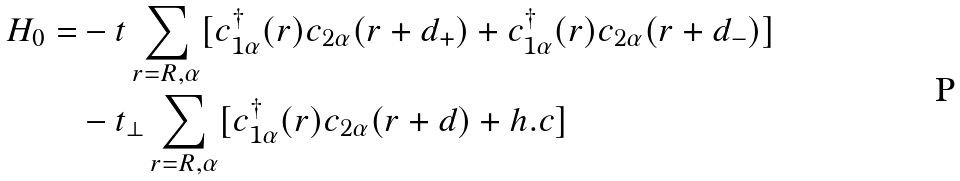Convert formula to latex. <formula><loc_0><loc_0><loc_500><loc_500>H _ { 0 } = & - t \sum _ { r = R , \alpha } [ c _ { 1 \alpha } ^ { \dag } ( r ) c _ { 2 \alpha } ( r + d _ { + } ) + c _ { 1 \alpha } ^ { \dag } ( r ) c _ { 2 \alpha } ( r + d _ { - } ) ] \\ & - t _ { \perp } \sum _ { r = R , \alpha } [ c _ { 1 \alpha } ^ { \dag } ( r ) c _ { 2 \alpha } ( r + d ) + h . c ]</formula> 